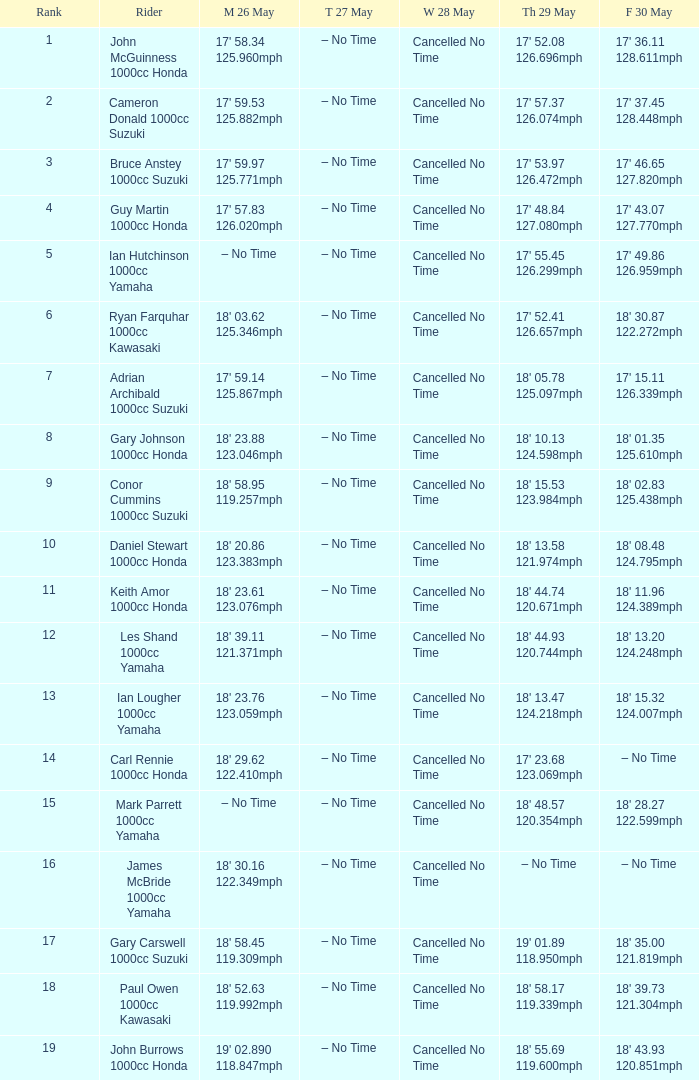What tims is wed may 28 and mon may 26 is 17' 58.34 125.960mph? Cancelled No Time. Write the full table. {'header': ['Rank', 'Rider', 'M 26 May', 'T 27 May', 'W 28 May', 'Th 29 May', 'F 30 May'], 'rows': [['1', 'John McGuinness 1000cc Honda', "17' 58.34 125.960mph", '– No Time', 'Cancelled No Time', "17' 52.08 126.696mph", "17' 36.11 128.611mph"], ['2', 'Cameron Donald 1000cc Suzuki', "17' 59.53 125.882mph", '– No Time', 'Cancelled No Time', "17' 57.37 126.074mph", "17' 37.45 128.448mph"], ['3', 'Bruce Anstey 1000cc Suzuki', "17' 59.97 125.771mph", '– No Time', 'Cancelled No Time', "17' 53.97 126.472mph", "17' 46.65 127.820mph"], ['4', 'Guy Martin 1000cc Honda', "17' 57.83 126.020mph", '– No Time', 'Cancelled No Time', "17' 48.84 127.080mph", "17' 43.07 127.770mph"], ['5', 'Ian Hutchinson 1000cc Yamaha', '– No Time', '– No Time', 'Cancelled No Time', "17' 55.45 126.299mph", "17' 49.86 126.959mph"], ['6', 'Ryan Farquhar 1000cc Kawasaki', "18' 03.62 125.346mph", '– No Time', 'Cancelled No Time', "17' 52.41 126.657mph", "18' 30.87 122.272mph"], ['7', 'Adrian Archibald 1000cc Suzuki', "17' 59.14 125.867mph", '– No Time', 'Cancelled No Time', "18' 05.78 125.097mph", "17' 15.11 126.339mph"], ['8', 'Gary Johnson 1000cc Honda', "18' 23.88 123.046mph", '– No Time', 'Cancelled No Time', "18' 10.13 124.598mph", "18' 01.35 125.610mph"], ['9', 'Conor Cummins 1000cc Suzuki', "18' 58.95 119.257mph", '– No Time', 'Cancelled No Time', "18' 15.53 123.984mph", "18' 02.83 125.438mph"], ['10', 'Daniel Stewart 1000cc Honda', "18' 20.86 123.383mph", '– No Time', 'Cancelled No Time', "18' 13.58 121.974mph", "18' 08.48 124.795mph"], ['11', 'Keith Amor 1000cc Honda', "18' 23.61 123.076mph", '– No Time', 'Cancelled No Time', "18' 44.74 120.671mph", "18' 11.96 124.389mph"], ['12', 'Les Shand 1000cc Yamaha', "18' 39.11 121.371mph", '– No Time', 'Cancelled No Time', "18' 44.93 120.744mph", "18' 13.20 124.248mph"], ['13', 'Ian Lougher 1000cc Yamaha', "18' 23.76 123.059mph", '– No Time', 'Cancelled No Time', "18' 13.47 124.218mph", "18' 15.32 124.007mph"], ['14', 'Carl Rennie 1000cc Honda', "18' 29.62 122.410mph", '– No Time', 'Cancelled No Time', "17' 23.68 123.069mph", '– No Time'], ['15', 'Mark Parrett 1000cc Yamaha', '– No Time', '– No Time', 'Cancelled No Time', "18' 48.57 120.354mph", "18' 28.27 122.599mph"], ['16', 'James McBride 1000cc Yamaha', "18' 30.16 122.349mph", '– No Time', 'Cancelled No Time', '– No Time', '– No Time'], ['17', 'Gary Carswell 1000cc Suzuki', "18' 58.45 119.309mph", '– No Time', 'Cancelled No Time', "19' 01.89 118.950mph", "18' 35.00 121.819mph"], ['18', 'Paul Owen 1000cc Kawasaki', "18' 52.63 119.992mph", '– No Time', 'Cancelled No Time', "18' 58.17 119.339mph", "18' 39.73 121.304mph"], ['19', 'John Burrows 1000cc Honda', "19' 02.890 118.847mph", '– No Time', 'Cancelled No Time', "18' 55.69 119.600mph", "18' 43.93 120.851mph"]]} 